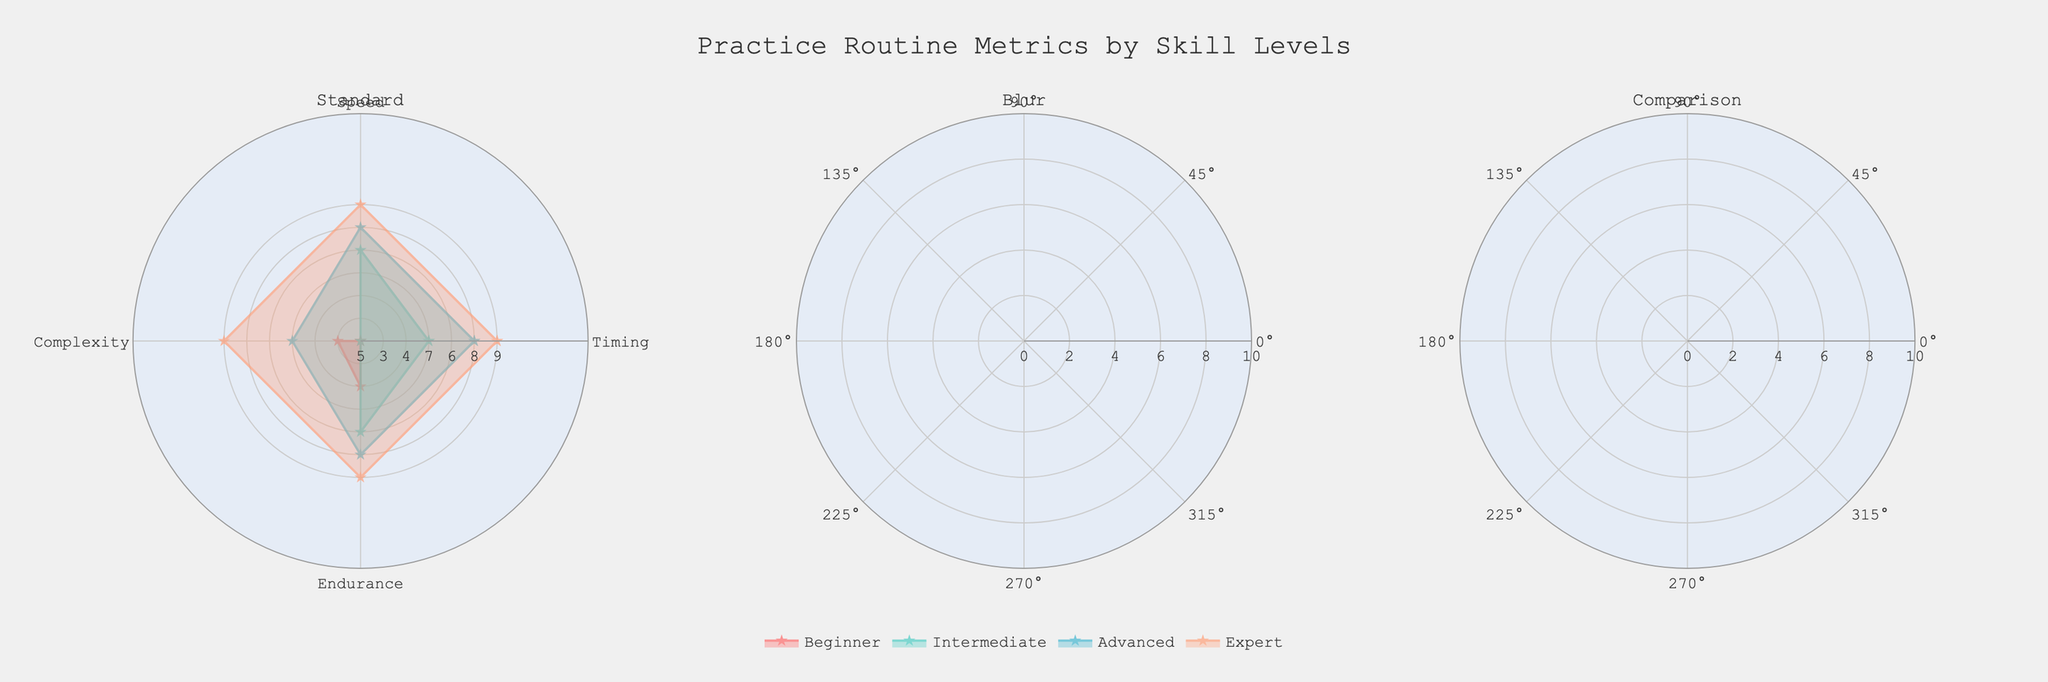What is the title of the figure? The title is usually displayed at the top of the chart. The title for this figure is located in the center at the top.
Answer: Practice Routine Metrics by Skill Levels How many subplots are present in the figure? The figure is divided into multiple sections side-by-side. Each section represents a different group. Count each distinct section.
Answer: Three Which skill level category shows the highest values across all metrics in the "Blur" subplot? In the "Blur" subplot, compare the value of each metric for every skill level. Find the skill level with the highest values in most or all metrics.
Answer: Blur Expert What is the difference in the "Speed" metric between "Blur Intermediate" and "Standard Intermediate"? Look at the "Speed" values for both "Blur Intermediate" and "Standard Intermediate" in their respective subplots and subtract the smaller value from the larger one.
Answer: 1 Compare the "Endurance" metric for "Blur Advanced" and "Comparison Advanced". Which one is higher and by how much? Locate the "Endurance" values for both "Blur Advanced" and "Comparison Advanced" in their subplots. Subtract the smaller value from the larger one to find the difference and identify which one is higher.
Answer: Blur Advanced by 1 What is the average value of the "Timing" metric for all skill levels in the "Standard" subplot? Add the values of the "Timing" metric for all skill levels (Beginner, Intermediate, Advanced, Expert) under the "Standard" subplot. Divide the sum by the number of skill levels (4).
Answer: 7.25 Which skill level in the "Comparison" subplot has the lowest value in any metric, and what is that value? Look for the minimum value across all metrics within the "Comparison" subplot for each skill level and identify the lowest value overall.
Answer: Comparison Beginner with a 4 in Endurance In the "Standard" subplot, which skill level shows the most significant increase in the "Complexity" metric compared to the previous skill level? Compare the "Complexity" metric for each subsequent skill level in the "Standard" subplot and find the skill level with the largest difference.
Answer: Intermediate (increase of 2 from Beginner to Intermediate) How does the "Speed" metric for "Blur Expert" compare to the "Speed" metric for "Expert" in the "Standard" subplot? Check the values of the "Speed" metric for "Blur Expert" and "Standard Expert" in their respective subplots and determine if they are equal, greater, or lesser.
Answer: Blur Expert is higher by 1 Which metric shows the smallest variation across all skill levels in the "Comparison" subplot? Review each metric (Timing, Speed, Complexity, Endurance) across all skill levels in the "Comparison" subplot and determine which has the smallest range (difference between highest and lowest values).
Answer: Complexity 